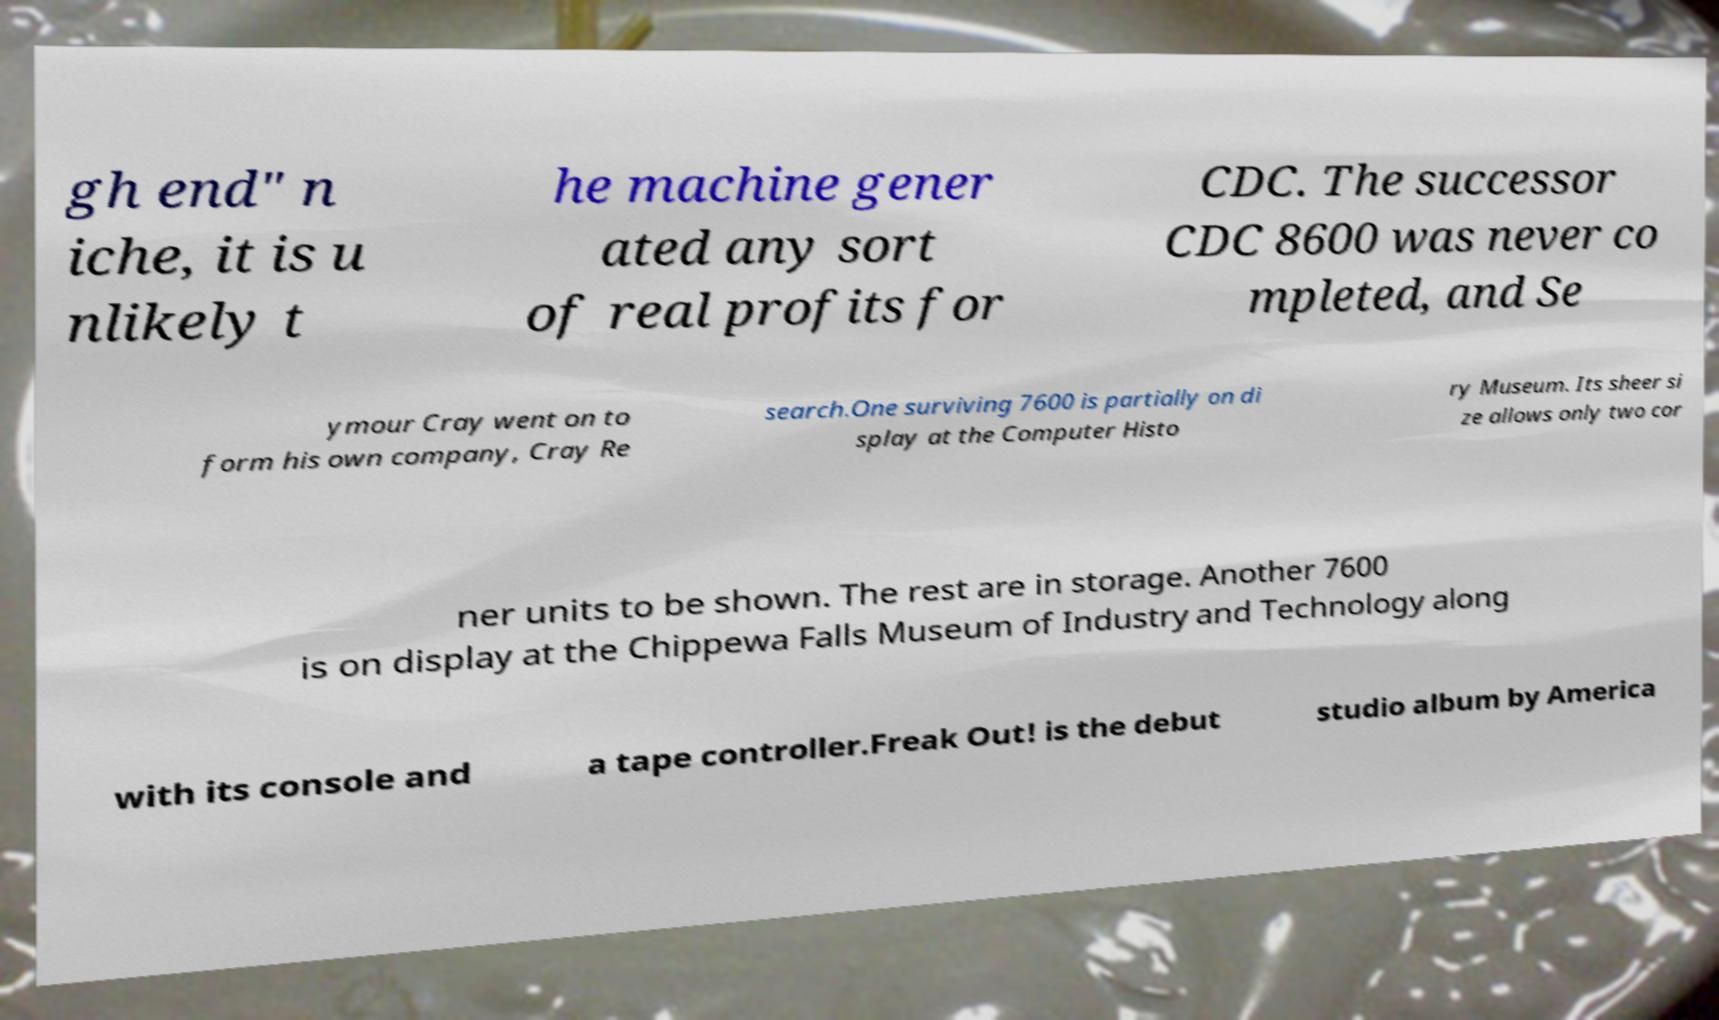Please identify and transcribe the text found in this image. gh end" n iche, it is u nlikely t he machine gener ated any sort of real profits for CDC. The successor CDC 8600 was never co mpleted, and Se ymour Cray went on to form his own company, Cray Re search.One surviving 7600 is partially on di splay at the Computer Histo ry Museum. Its sheer si ze allows only two cor ner units to be shown. The rest are in storage. Another 7600 is on display at the Chippewa Falls Museum of Industry and Technology along with its console and a tape controller.Freak Out! is the debut studio album by America 